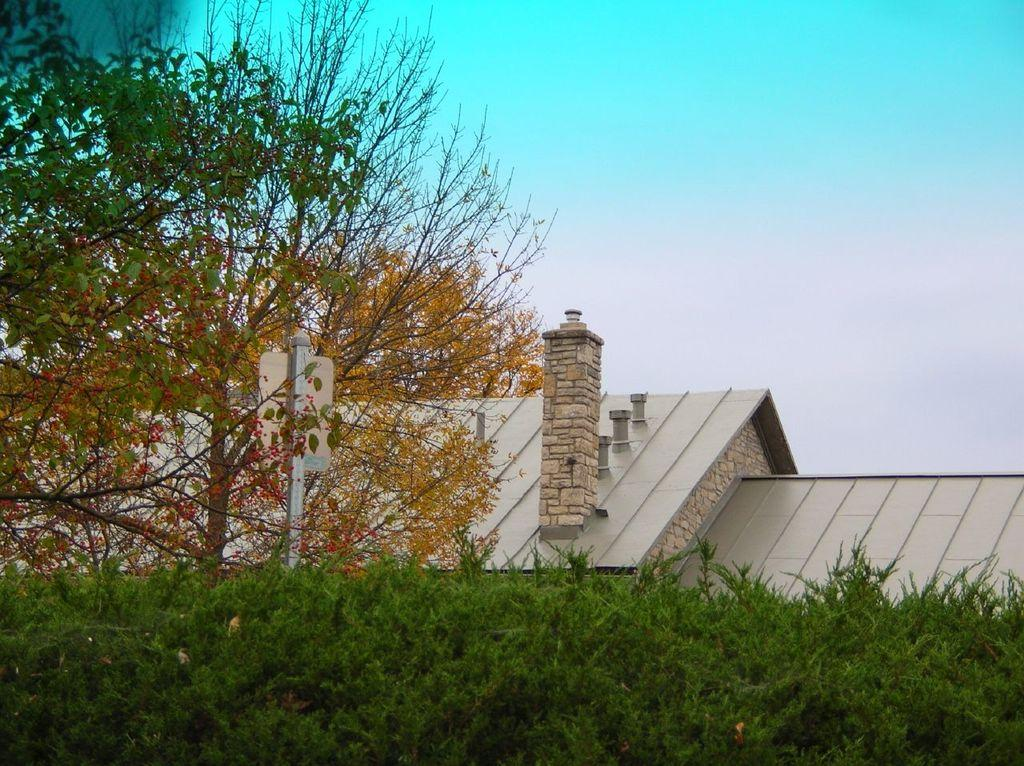What type of plant is visible in the image? There is a grass plant in the image. What other types of vegetation can be seen in the image? There are trees in the image. What can be seen in the background of the image? There are buildings in the background of the image. What is visible in the sky in the image? The sky is visible in the image, and it is blue in color. Can you tell me how many questions are being asked in the image? There are no questions visible in the image; it is a photograph of a grass plant, trees, buildings, and the sky. Is there a dog present in the image? No, there is no dog present in the image. 